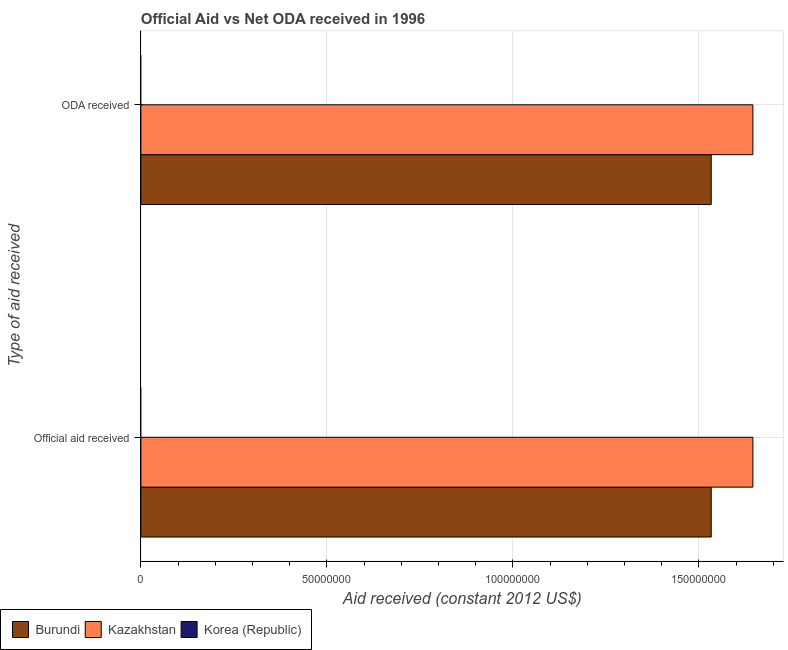How many different coloured bars are there?
Your response must be concise. 2. How many groups of bars are there?
Your answer should be very brief. 2. Are the number of bars on each tick of the Y-axis equal?
Give a very brief answer. Yes. What is the label of the 1st group of bars from the top?
Provide a short and direct response. ODA received. What is the official aid received in Kazakhstan?
Ensure brevity in your answer.  1.64e+08. Across all countries, what is the maximum official aid received?
Provide a short and direct response. 1.64e+08. Across all countries, what is the minimum oda received?
Make the answer very short. 0. In which country was the official aid received maximum?
Offer a terse response. Kazakhstan. What is the total official aid received in the graph?
Offer a terse response. 3.18e+08. What is the difference between the oda received in Kazakhstan and that in Burundi?
Ensure brevity in your answer.  1.12e+07. What is the difference between the official aid received in Kazakhstan and the oda received in Korea (Republic)?
Provide a short and direct response. 1.64e+08. What is the average official aid received per country?
Offer a very short reply. 1.06e+08. What is the difference between the oda received and official aid received in Burundi?
Provide a succinct answer. 0. In how many countries, is the oda received greater than 120000000 US$?
Make the answer very short. 2. What is the ratio of the oda received in Kazakhstan to that in Burundi?
Provide a succinct answer. 1.07. Is the oda received in Burundi less than that in Kazakhstan?
Provide a short and direct response. Yes. In how many countries, is the official aid received greater than the average official aid received taken over all countries?
Your response must be concise. 2. Are all the bars in the graph horizontal?
Provide a short and direct response. Yes. How many countries are there in the graph?
Provide a short and direct response. 3. What is the difference between two consecutive major ticks on the X-axis?
Give a very brief answer. 5.00e+07. Where does the legend appear in the graph?
Offer a very short reply. Bottom left. What is the title of the graph?
Offer a very short reply. Official Aid vs Net ODA received in 1996 . Does "Kuwait" appear as one of the legend labels in the graph?
Your response must be concise. No. What is the label or title of the X-axis?
Give a very brief answer. Aid received (constant 2012 US$). What is the label or title of the Y-axis?
Make the answer very short. Type of aid received. What is the Aid received (constant 2012 US$) in Burundi in Official aid received?
Offer a very short reply. 1.53e+08. What is the Aid received (constant 2012 US$) of Kazakhstan in Official aid received?
Offer a very short reply. 1.64e+08. What is the Aid received (constant 2012 US$) of Burundi in ODA received?
Your response must be concise. 1.53e+08. What is the Aid received (constant 2012 US$) in Kazakhstan in ODA received?
Make the answer very short. 1.64e+08. What is the Aid received (constant 2012 US$) of Korea (Republic) in ODA received?
Give a very brief answer. 0. Across all Type of aid received, what is the maximum Aid received (constant 2012 US$) of Burundi?
Offer a terse response. 1.53e+08. Across all Type of aid received, what is the maximum Aid received (constant 2012 US$) in Kazakhstan?
Provide a succinct answer. 1.64e+08. Across all Type of aid received, what is the minimum Aid received (constant 2012 US$) in Burundi?
Give a very brief answer. 1.53e+08. Across all Type of aid received, what is the minimum Aid received (constant 2012 US$) in Kazakhstan?
Offer a terse response. 1.64e+08. What is the total Aid received (constant 2012 US$) in Burundi in the graph?
Offer a very short reply. 3.07e+08. What is the total Aid received (constant 2012 US$) in Kazakhstan in the graph?
Provide a succinct answer. 3.29e+08. What is the total Aid received (constant 2012 US$) of Korea (Republic) in the graph?
Keep it short and to the point. 0. What is the difference between the Aid received (constant 2012 US$) of Burundi in Official aid received and that in ODA received?
Provide a short and direct response. 0. What is the difference between the Aid received (constant 2012 US$) of Burundi in Official aid received and the Aid received (constant 2012 US$) of Kazakhstan in ODA received?
Provide a succinct answer. -1.12e+07. What is the average Aid received (constant 2012 US$) of Burundi per Type of aid received?
Your response must be concise. 1.53e+08. What is the average Aid received (constant 2012 US$) of Kazakhstan per Type of aid received?
Provide a short and direct response. 1.64e+08. What is the difference between the Aid received (constant 2012 US$) of Burundi and Aid received (constant 2012 US$) of Kazakhstan in Official aid received?
Provide a short and direct response. -1.12e+07. What is the difference between the Aid received (constant 2012 US$) in Burundi and Aid received (constant 2012 US$) in Kazakhstan in ODA received?
Offer a very short reply. -1.12e+07. What is the ratio of the Aid received (constant 2012 US$) in Burundi in Official aid received to that in ODA received?
Ensure brevity in your answer.  1. What is the ratio of the Aid received (constant 2012 US$) of Kazakhstan in Official aid received to that in ODA received?
Provide a succinct answer. 1. What is the difference between the highest and the second highest Aid received (constant 2012 US$) in Burundi?
Your answer should be very brief. 0. What is the difference between the highest and the lowest Aid received (constant 2012 US$) of Burundi?
Your answer should be very brief. 0. 